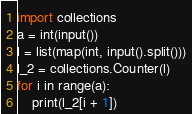<code> <loc_0><loc_0><loc_500><loc_500><_Python_>import collections
a = int(input())
l = list(map(int, input().split()))
l_2 = collections.Counter(l)
for i in range(a):
    print(l_2[i + 1])
</code> 